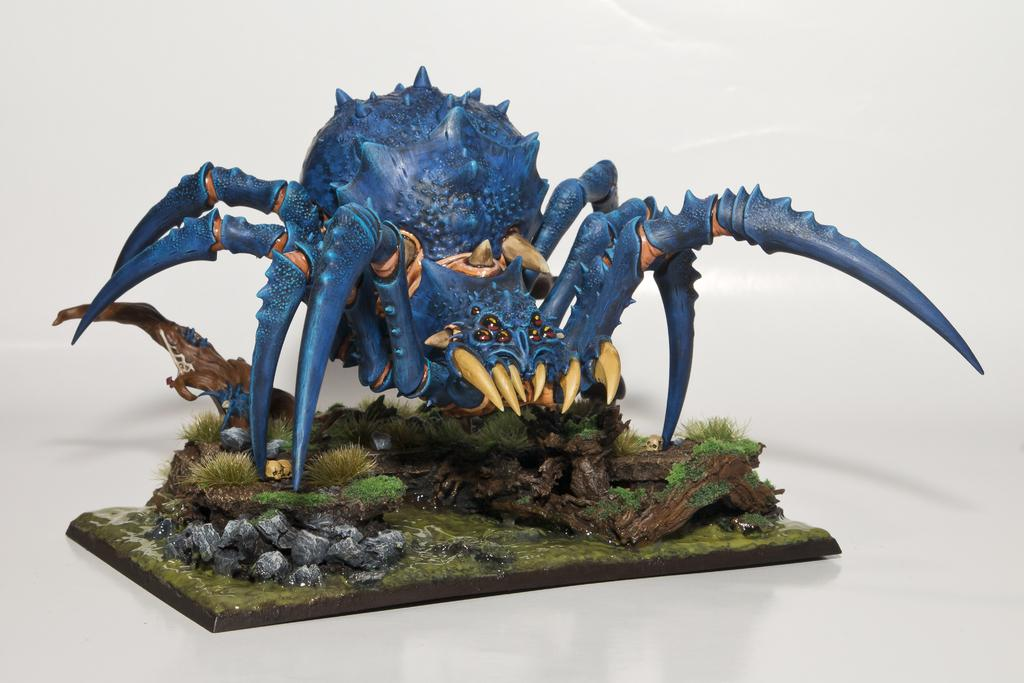What type of animal is depicted by the statue in the image? The statue is a blue color animal. What is the color of the animal statue? The color of the animal statue is blue. What is the surface on which the statue is placed? The statue is on a white surface. Can you see any waves crashing against the statue in the image? There are no waves present in the image, and therefore no such interaction can be observed. Are there any railings surrounding the statue in the image? There is no mention of railings in the provided facts, and therefore it cannot be determined if they are present in the image. --- Facts: 1. There is a person holding a camera in the image. 2. The person is standing on a bridge. 3. The bridge is over a river. 4. There are trees on both sides of the river. Absurd Topics: parrot, bicycle, sandcastle Conversation: What is the person in the image holding? The person in the image is holding a camera. Where is the person standing in the image? The person is standing on a bridge. What is the bridge positioned over in the image? The bridge is over a river. What type of vegetation can be seen near the river in the image? There are trees on both sides of the river. Reasoning: Let's think step by step in order to produce the conversation. We start by identifying the main subject in the image, which is the person holding a camera. Then, we describe the location of the person, which is on a bridge. Next, we mention the body of water that the bridge is positioned over, which is a river. Finally, we describe the type of vegetation that can be seen near the river, which are trees. Absurd Question/Answer: Can you see any parrots perched on the person's shoulder in the image? There is no mention of parrots in the provided facts, and therefore it cannot be determined if they are present in the image. Is there a bicycle visible on the bridge in the image? There is no mention of a bicycle in the provided facts, and therefore it cannot be determined if it is present in the image. 